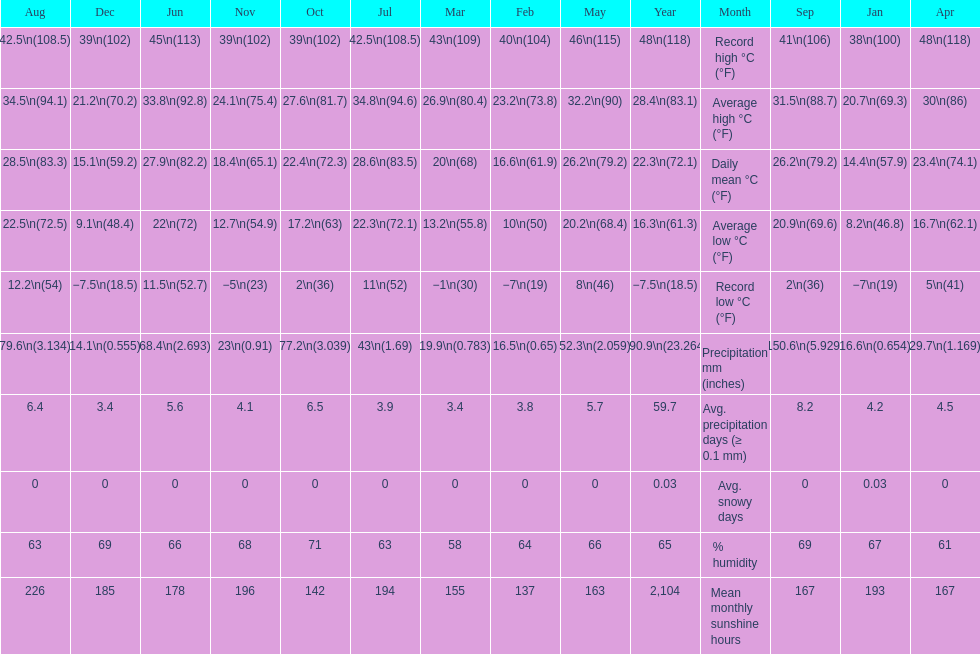Did march or april have more precipitation? April. 